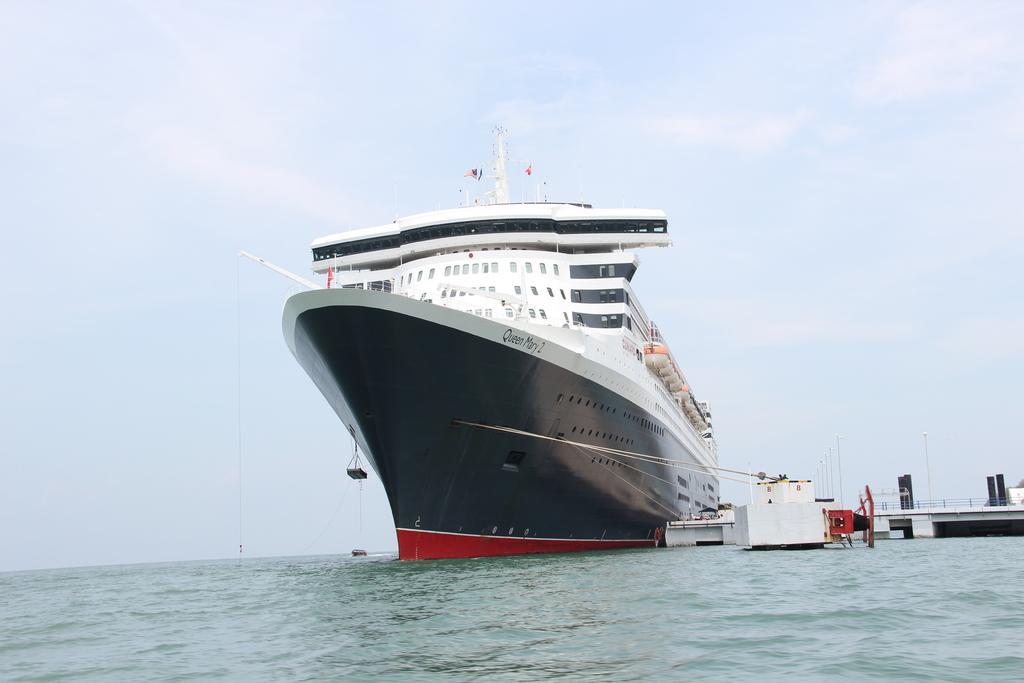How would you summarize this image in a sentence or two? In this picture we can see ship and boats above the water and we can see platform, fence, poles and flag. In the background of the image we can see the sky with clouds. 